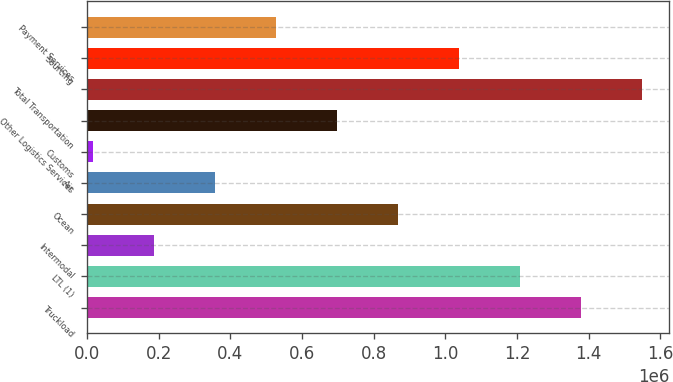Convert chart. <chart><loc_0><loc_0><loc_500><loc_500><bar_chart><fcel>Truckload<fcel>LTL (1)<fcel>Intermodal<fcel>Ocean<fcel>Air<fcel>Customs<fcel>Other Logistics Services<fcel>Total Transportation<fcel>Sourcing<fcel>Payment Services<nl><fcel>1.3777e+06<fcel>1.20777e+06<fcel>188160<fcel>867898<fcel>358094<fcel>18225<fcel>697963<fcel>1.54764e+06<fcel>1.03783e+06<fcel>528029<nl></chart> 